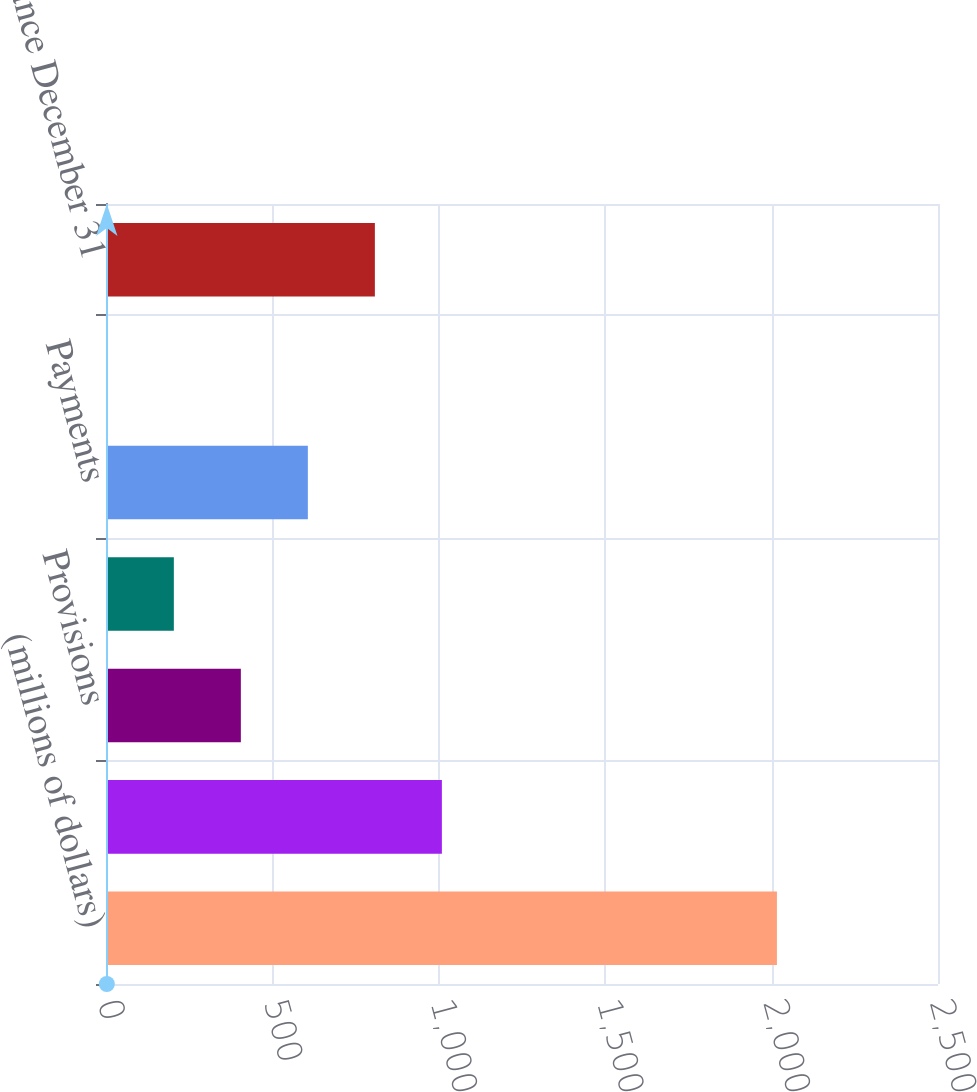<chart> <loc_0><loc_0><loc_500><loc_500><bar_chart><fcel>(millions of dollars)<fcel>Beginning balance January 1<fcel>Provisions<fcel>Acquisitions<fcel>Payments<fcel>Translation adjustment<fcel>Ending balance December 31<nl><fcel>2016<fcel>1009.25<fcel>405.2<fcel>203.85<fcel>606.55<fcel>2.5<fcel>807.9<nl></chart> 